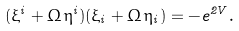<formula> <loc_0><loc_0><loc_500><loc_500>( \xi ^ { i } + \Omega \, \eta ^ { i } ) ( \xi _ { i } + \Omega \, \eta _ { i } ) = - e ^ { 2 V } .</formula> 